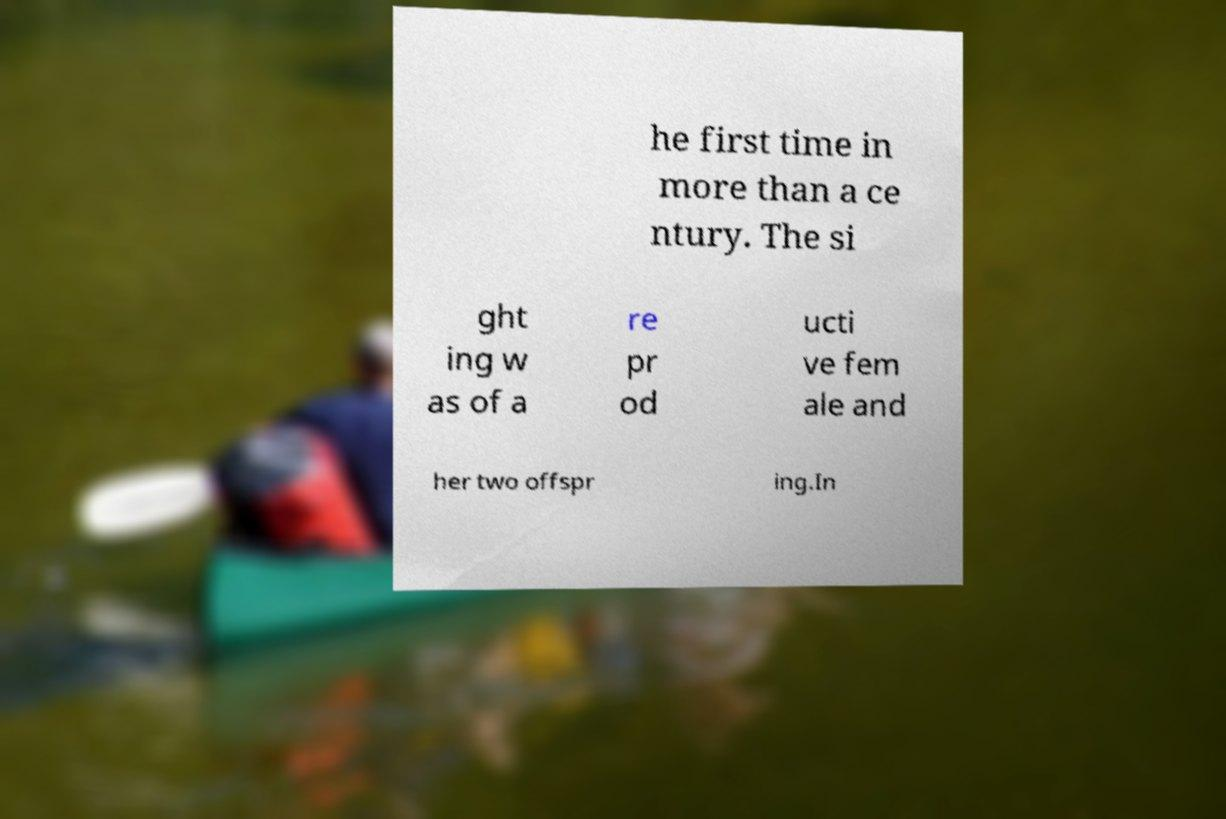There's text embedded in this image that I need extracted. Can you transcribe it verbatim? he first time in more than a ce ntury. The si ght ing w as of a re pr od ucti ve fem ale and her two offspr ing.In 